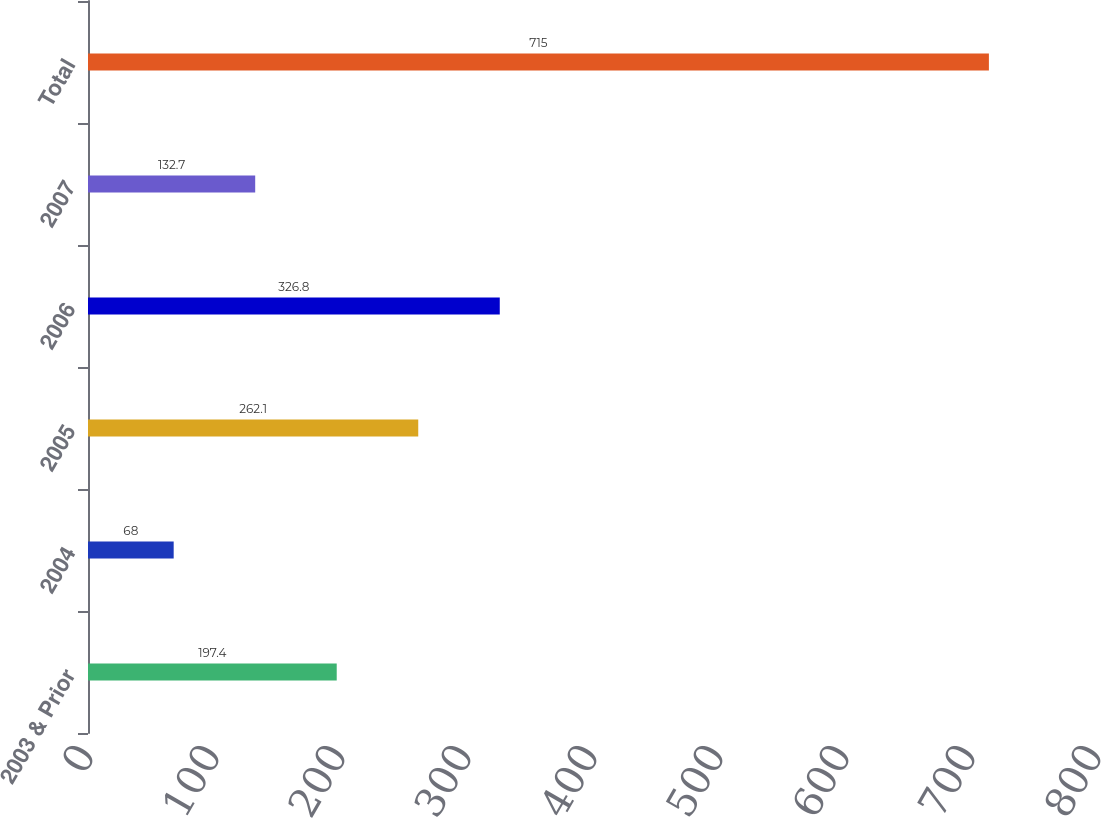<chart> <loc_0><loc_0><loc_500><loc_500><bar_chart><fcel>2003 & Prior<fcel>2004<fcel>2005<fcel>2006<fcel>2007<fcel>Total<nl><fcel>197.4<fcel>68<fcel>262.1<fcel>326.8<fcel>132.7<fcel>715<nl></chart> 